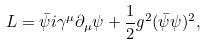Convert formula to latex. <formula><loc_0><loc_0><loc_500><loc_500>L = \bar { \psi } i \gamma ^ { \mu } \partial _ { \mu } \psi + \frac { 1 } { 2 } g ^ { 2 } ( \bar { \psi } \psi ) ^ { 2 } ,</formula> 